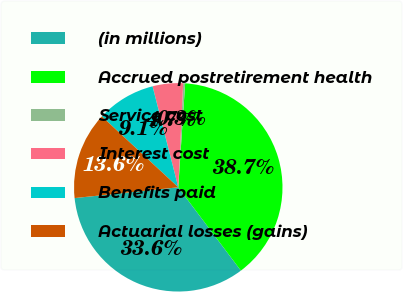Convert chart. <chart><loc_0><loc_0><loc_500><loc_500><pie_chart><fcel>(in millions)<fcel>Accrued postretirement health<fcel>Service cost<fcel>Interest cost<fcel>Benefits paid<fcel>Actuarial losses (gains)<nl><fcel>33.61%<fcel>38.69%<fcel>0.3%<fcel>4.72%<fcel>9.13%<fcel>13.55%<nl></chart> 